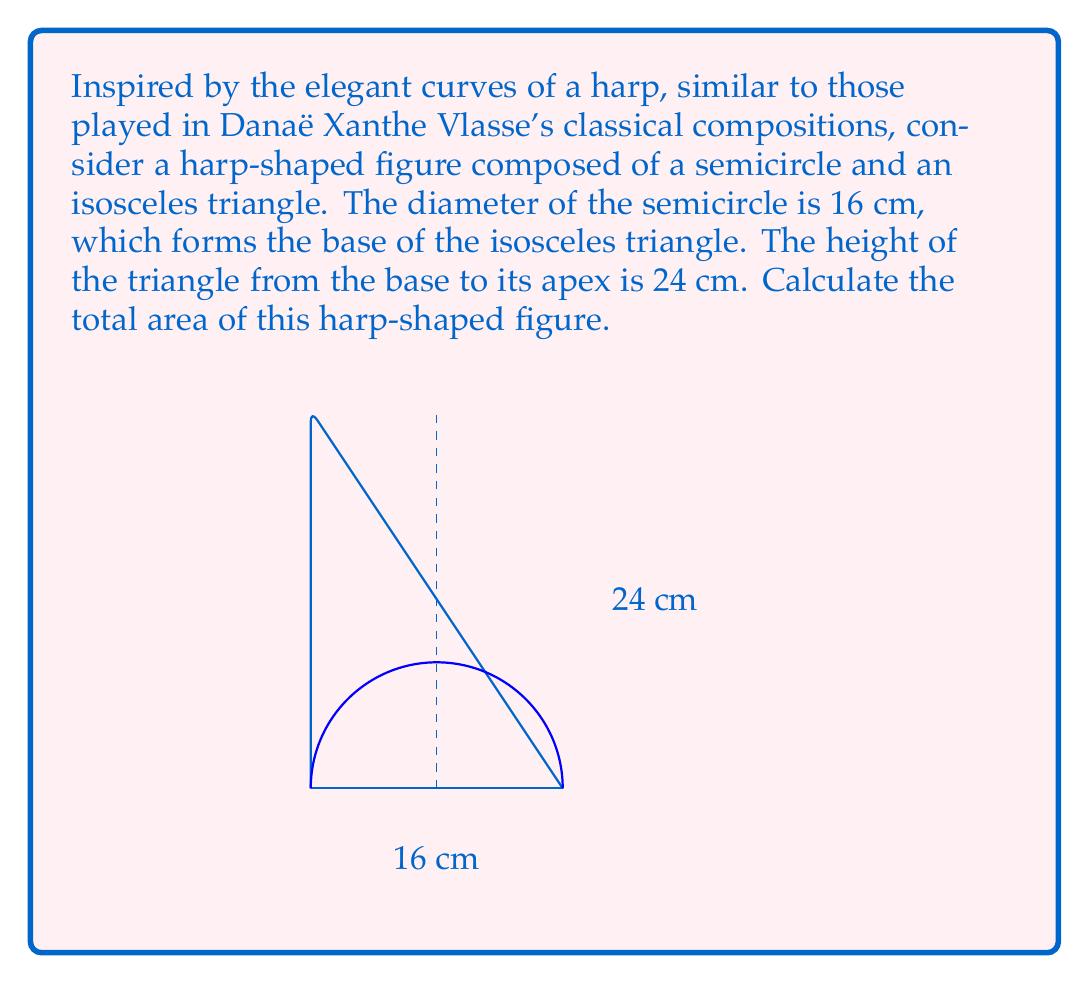Can you solve this math problem? To solve this problem, we need to calculate the areas of the semicircle and the isosceles triangle separately, then sum them up. Let's break it down step-by-step:

1. Area of the semicircle:
   - The diameter is 16 cm, so the radius is 8 cm.
   - Area of a semicircle = $\frac{1}{2} \pi r^2$
   - $A_{semicircle} = \frac{1}{2} \pi (8^2) = 32\pi$ cm²

2. Area of the isosceles triangle:
   - Base of the triangle is 16 cm (same as the diameter of the semicircle)
   - Height of the triangle is 24 cm
   - Area of a triangle = $\frac{1}{2} \times base \times height$
   - $A_{triangle} = \frac{1}{2} \times 16 \times 24 = 192$ cm²

3. Total area of the harp-shaped figure:
   - $A_{total} = A_{semicircle} + A_{triangle}$
   - $A_{total} = 32\pi + 192$ cm²

4. Simplifying the expression:
   - $A_{total} = 32\pi + 192$ cm²
   - This cannot be simplified further as $\pi$ is an irrational number.

Therefore, the total area of the harp-shaped figure is $32\pi + 192$ square centimeters.
Answer: $32\pi + 192$ cm² 